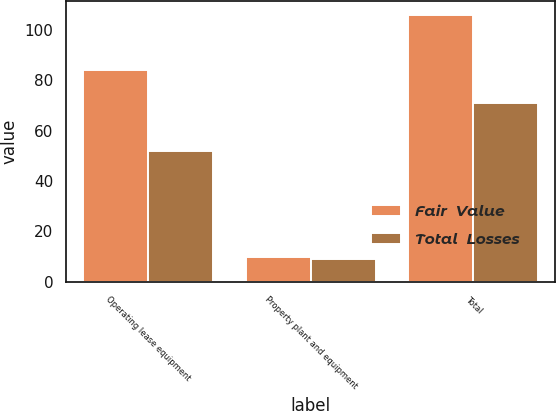Convert chart to OTSL. <chart><loc_0><loc_0><loc_500><loc_500><stacked_bar_chart><ecel><fcel>Operating lease equipment<fcel>Property plant and equipment<fcel>Total<nl><fcel>Fair  Value<fcel>84<fcel>10<fcel>106<nl><fcel>Total  Losses<fcel>52<fcel>9<fcel>71<nl></chart> 